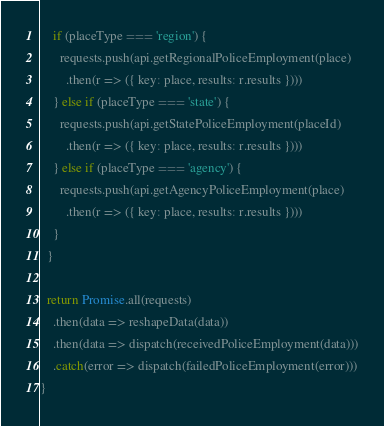Convert code to text. <code><loc_0><loc_0><loc_500><loc_500><_JavaScript_>    if (placeType === 'region') {
      requests.push(api.getRegionalPoliceEmployment(place)
        .then(r => ({ key: place, results: r.results })))
    } else if (placeType === 'state') {
      requests.push(api.getStatePoliceEmployment(placeId)
        .then(r => ({ key: place, results: r.results })))
    } else if (placeType === 'agency') {
      requests.push(api.getAgencyPoliceEmployment(place)
        .then(r => ({ key: place, results: r.results })))
    }
  }

  return Promise.all(requests)
    .then(data => reshapeData(data))
    .then(data => dispatch(receivedPoliceEmployment(data)))
    .catch(error => dispatch(failedPoliceEmployment(error)))
}
</code> 